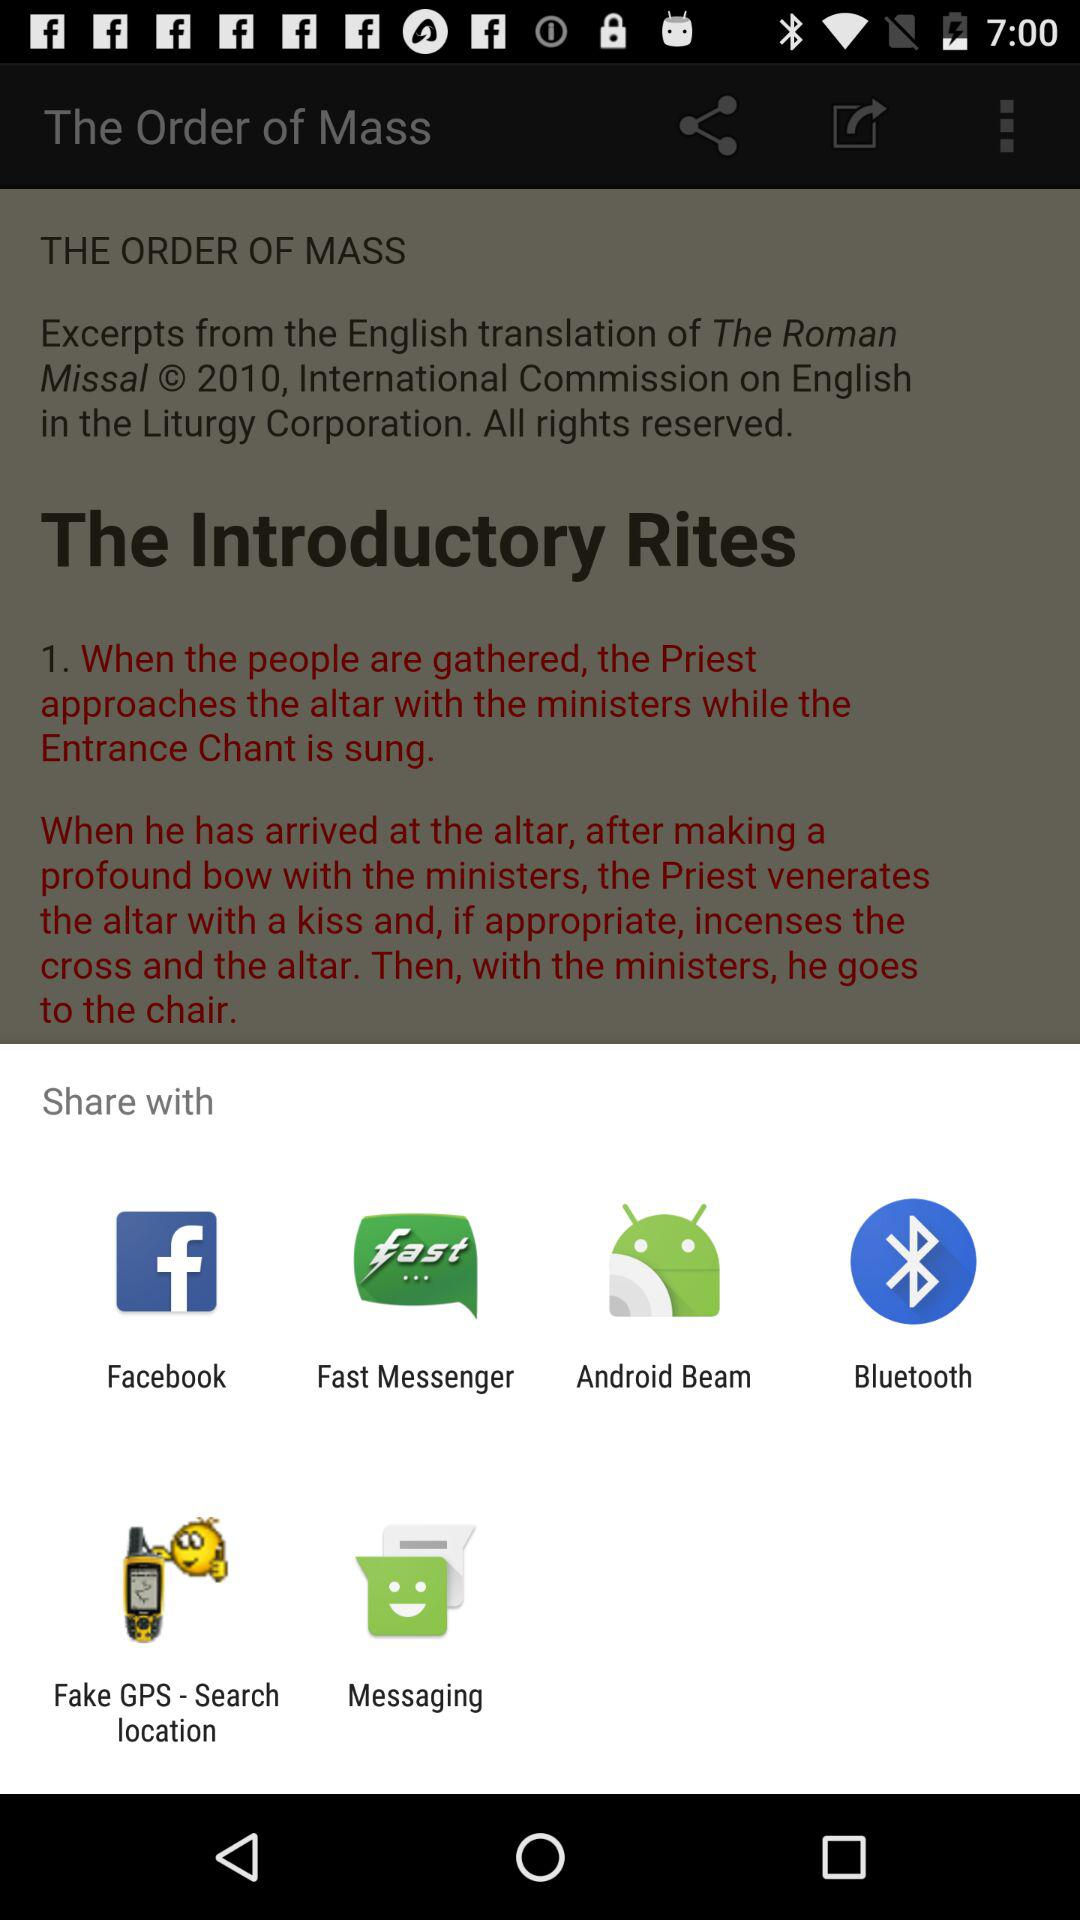What are the other sharing options? The sharing options are "Facebook", "Fast Messenger", "Android Beam", "Bluetooth", "Fake GPS - Search location" and "Messaging". 